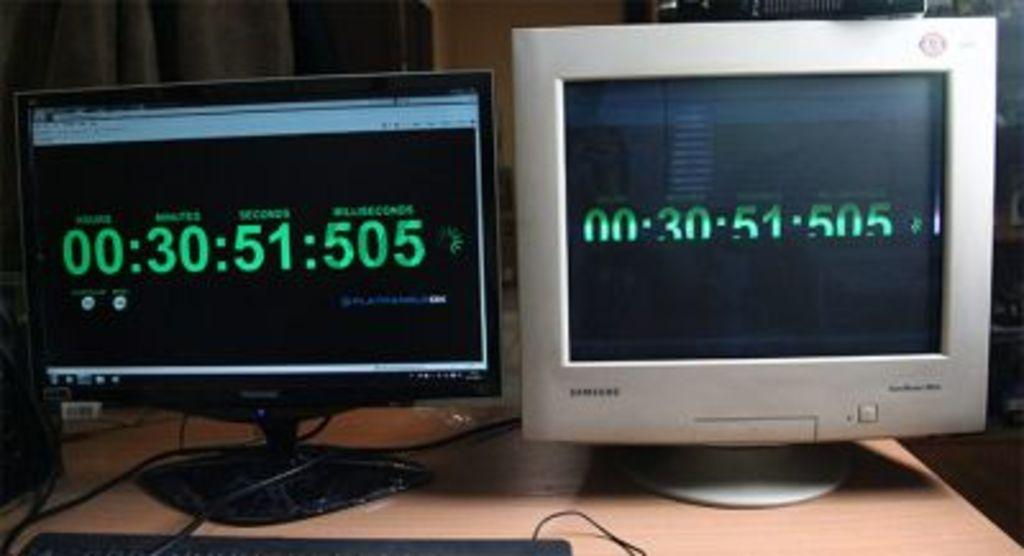<image>
Render a clear and concise summary of the photo. Two computer monitors side by side, one a flat panel screen, the other a CRT monitor, both showing that there are 30 minutes and 51 seconds remaining. 